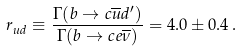Convert formula to latex. <formula><loc_0><loc_0><loc_500><loc_500>r _ { u d } \equiv \frac { \Gamma ( b \to c \overline { u } d ^ { \prime } ) } { \Gamma ( b \to c e \overline { \nu } ) } = 4 . 0 \pm 0 . 4 \, .</formula> 